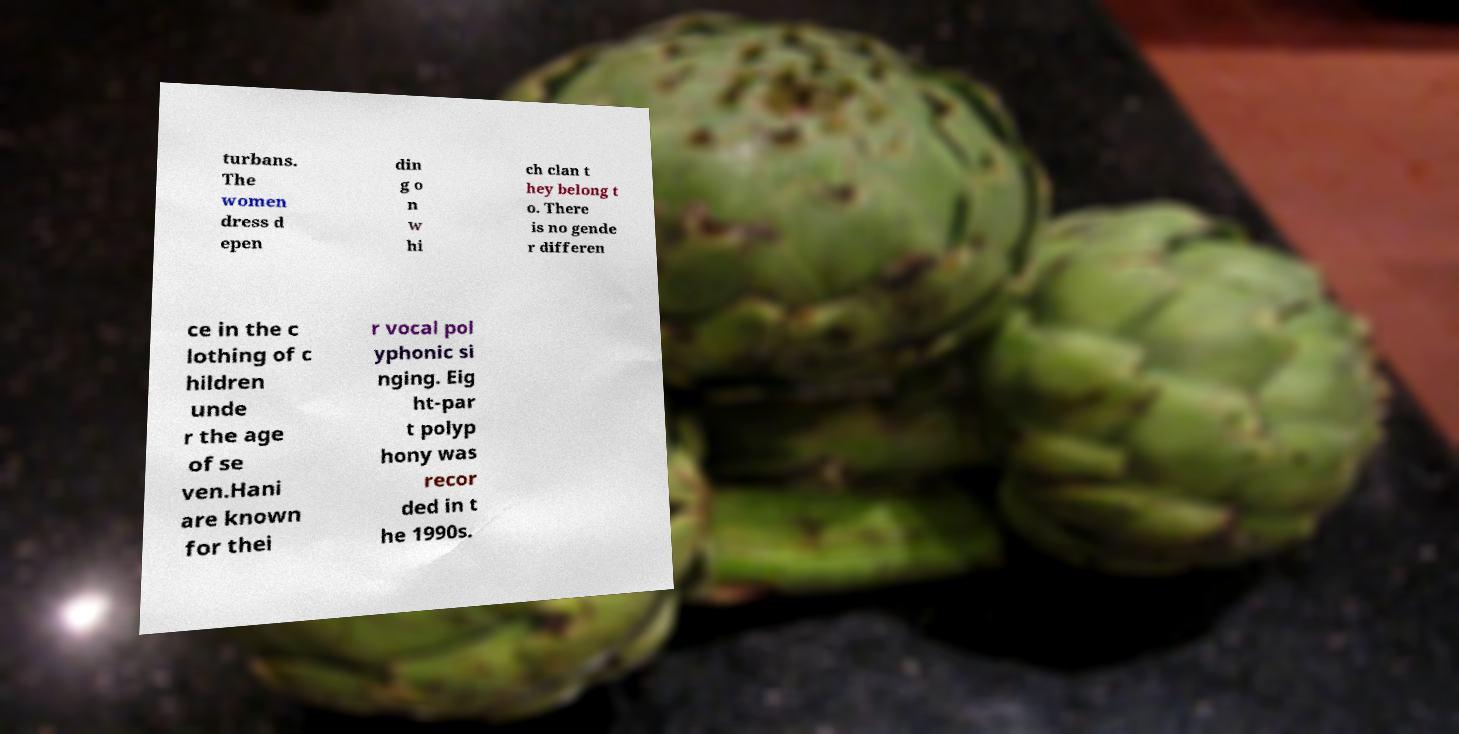Please read and relay the text visible in this image. What does it say? turbans. The women dress d epen din g o n w hi ch clan t hey belong t o. There is no gende r differen ce in the c lothing of c hildren unde r the age of se ven.Hani are known for thei r vocal pol yphonic si nging. Eig ht-par t polyp hony was recor ded in t he 1990s. 